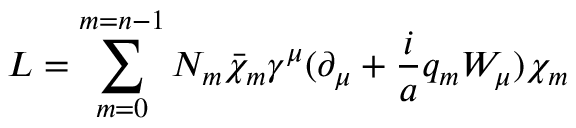<formula> <loc_0><loc_0><loc_500><loc_500>L = \sum _ { m = 0 } ^ { m = n - 1 } N _ { m } \bar { \chi } _ { m } \gamma ^ { \mu } ( \partial _ { \mu } + \frac { i } { a } q _ { m } W _ { \mu } ) \chi _ { m }</formula> 